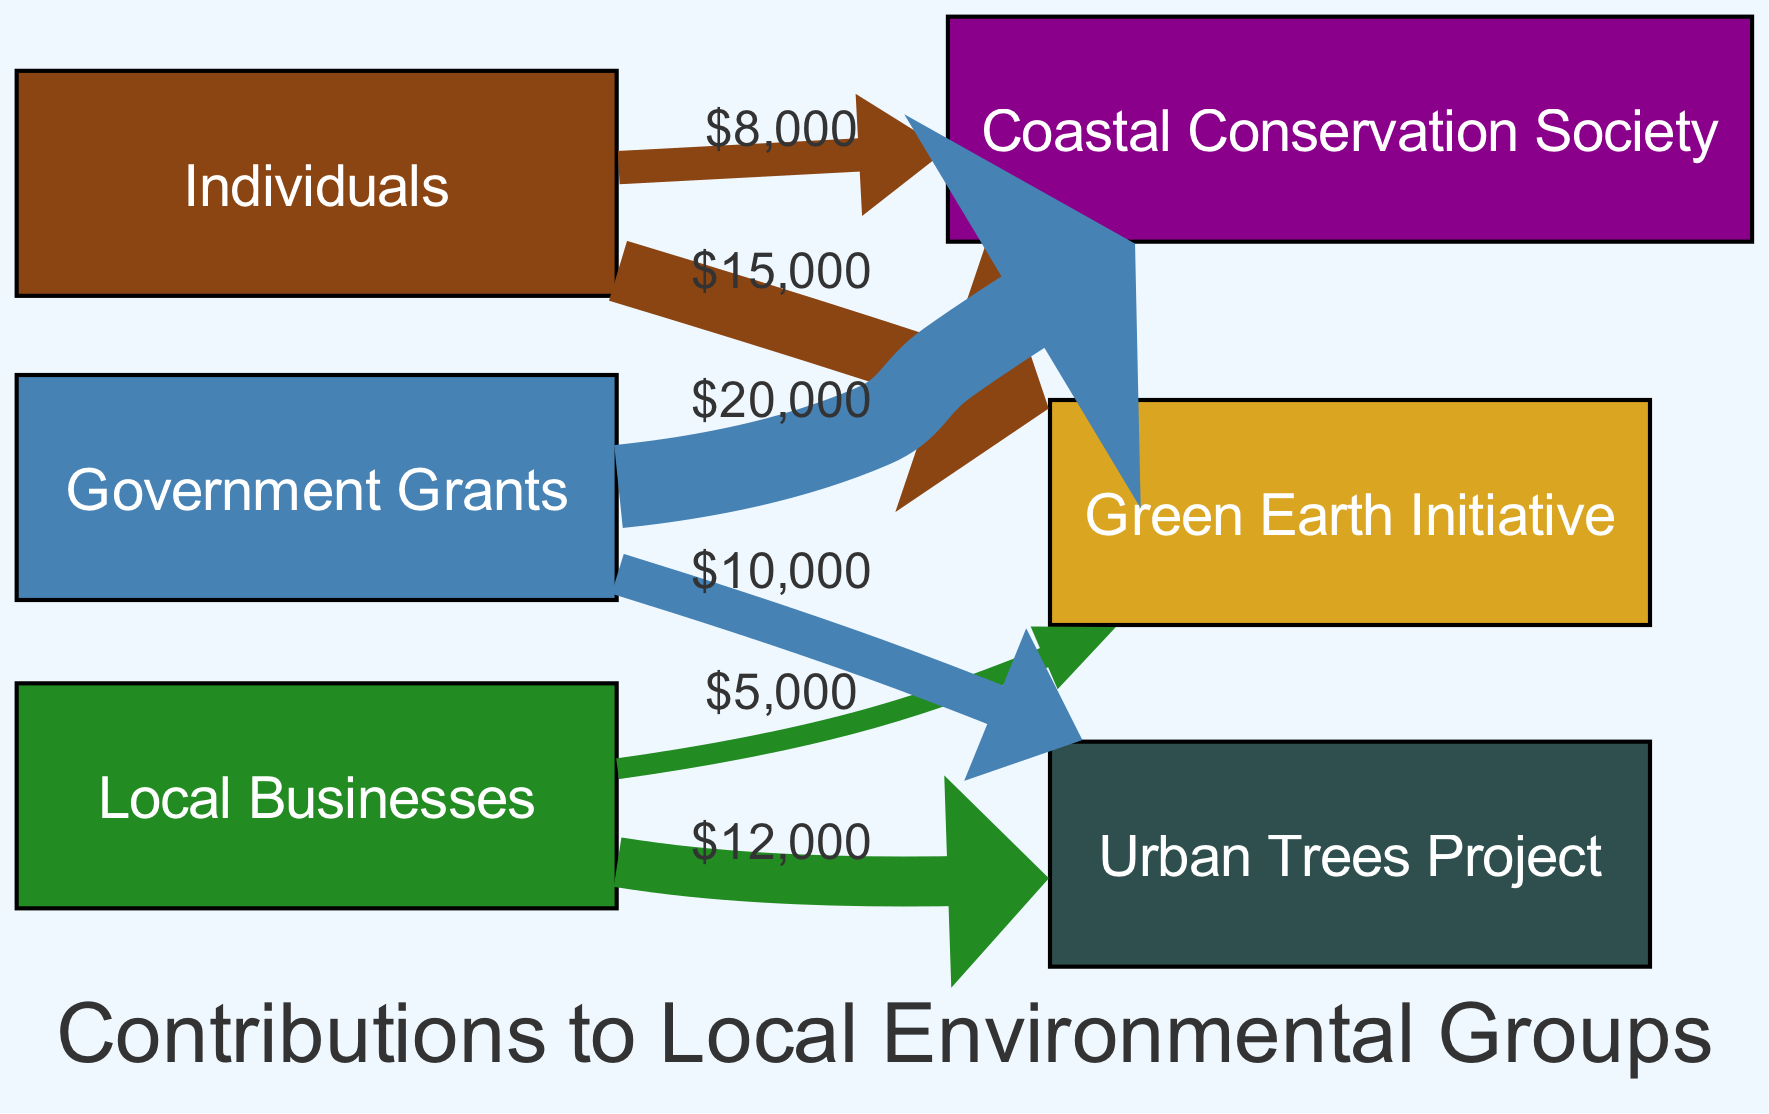What is the total amount donated by individuals to the Green Earth Initiative? By examining the link between "Individuals" and "Green Earth Initiative," we see a donation value of 15,000.
Answer: 15,000 Which organization received the highest funding from government grants? Looking at the links from "Government Grants," the "Coastal Conservation Society" received 20,000, which is higher than any other organization's grant funding.
Answer: Coastal Conservation Society How many organizations are supported by local businesses? There are two links coming from "Local Businesses": one to "Urban Trees Project" and another to "Green Earth Initiative." Thus, there are two organizations.
Answer: 2 What is the total amount received by the Coastal Conservation Society? The Coastal Conservation Society has two sources of funding: 8,000 from individuals and 20,000 from government grants, amounting to a total of 28,000 when summed.
Answer: 28,000 Is the amount donated by local businesses to the Urban Trees Project higher than that from individuals to the Coastal Conservation Society? The "Local Businesses" donated 12,000 to the "Urban Trees Project," while "Individuals" donated 8,000 to the "Coastal Conservation Society." Comparing these amounts shows that 12,000 is indeed higher than 8,000.
Answer: Yes 